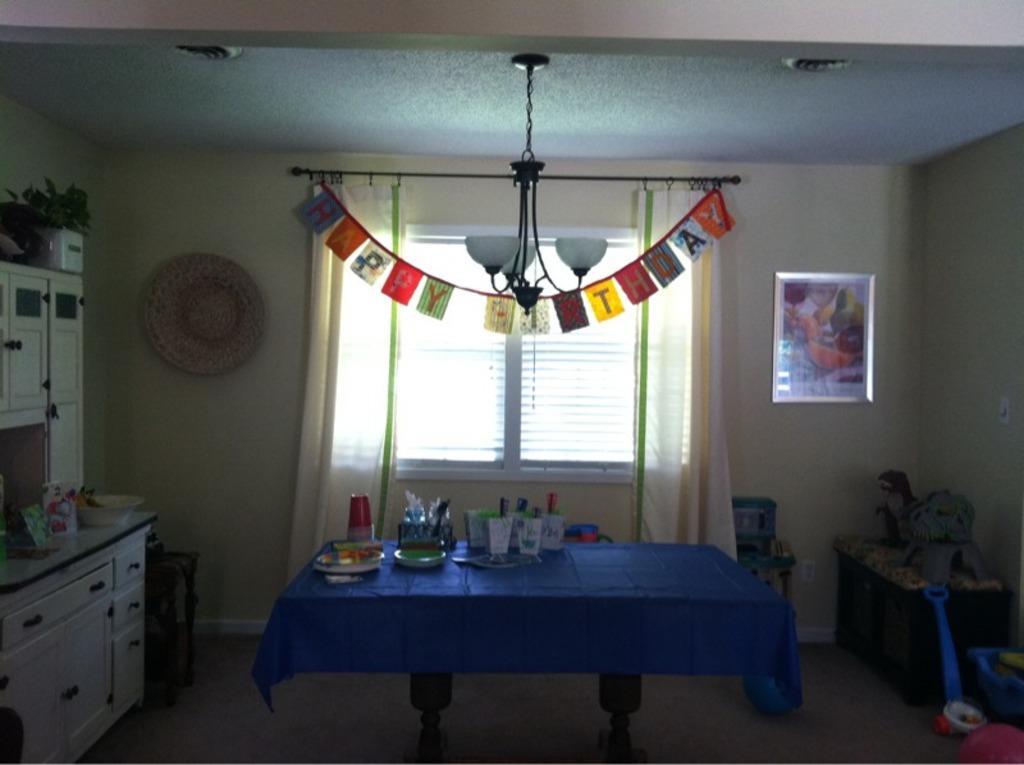Could you give a brief overview of what you see in this image? In this image we can see a table. On the table there is a cloth, plates, bottle, and other objects. Here we can see floor, cupboards, decorative objects, bowl, plant, and other objects. In the background we can see wall, ceiling, lights, frame, window, and curtains. 